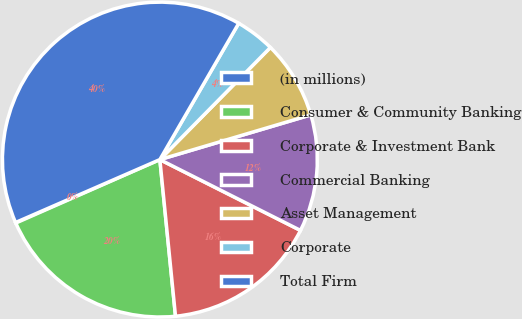<chart> <loc_0><loc_0><loc_500><loc_500><pie_chart><fcel>(in millions)<fcel>Consumer & Community Banking<fcel>Corporate & Investment Bank<fcel>Commercial Banking<fcel>Asset Management<fcel>Corporate<fcel>Total Firm<nl><fcel>0.06%<fcel>19.98%<fcel>15.99%<fcel>12.01%<fcel>8.03%<fcel>4.04%<fcel>39.89%<nl></chart> 